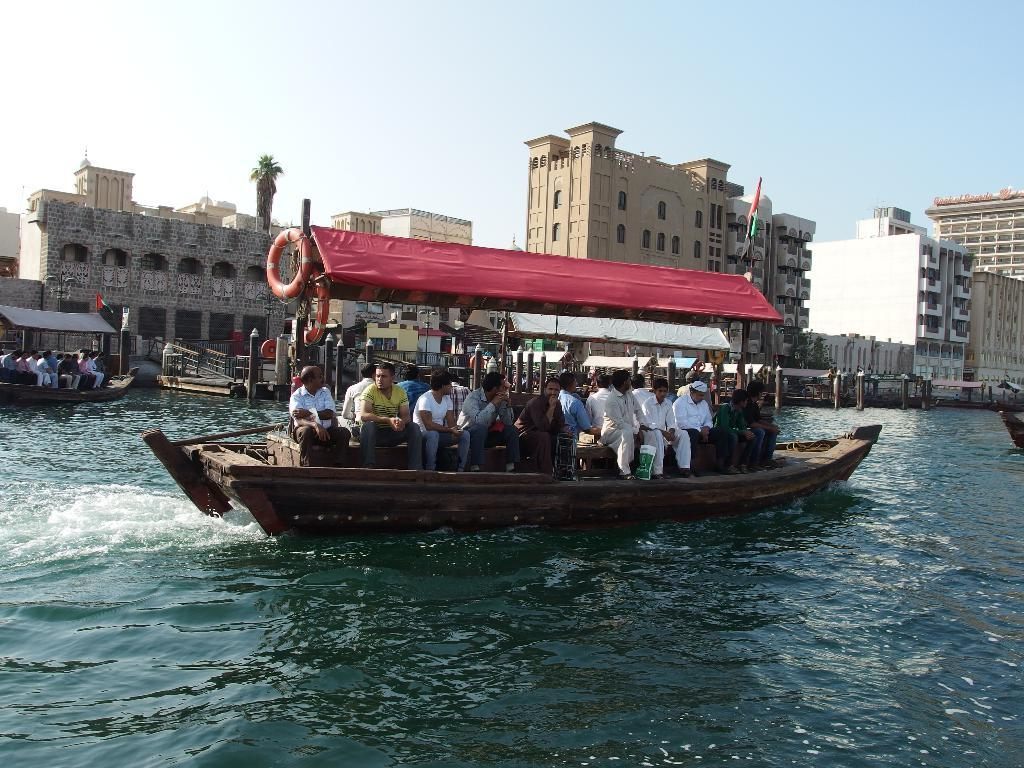What are the people in the image doing? The people are sitting on boats in the image. What is visible in the background of the image? There is water, buildings, and the sky visible in the background of the image. What type of bells can be heard ringing in the image? There are no bells present in the image, and therefore no sound can be heard. 